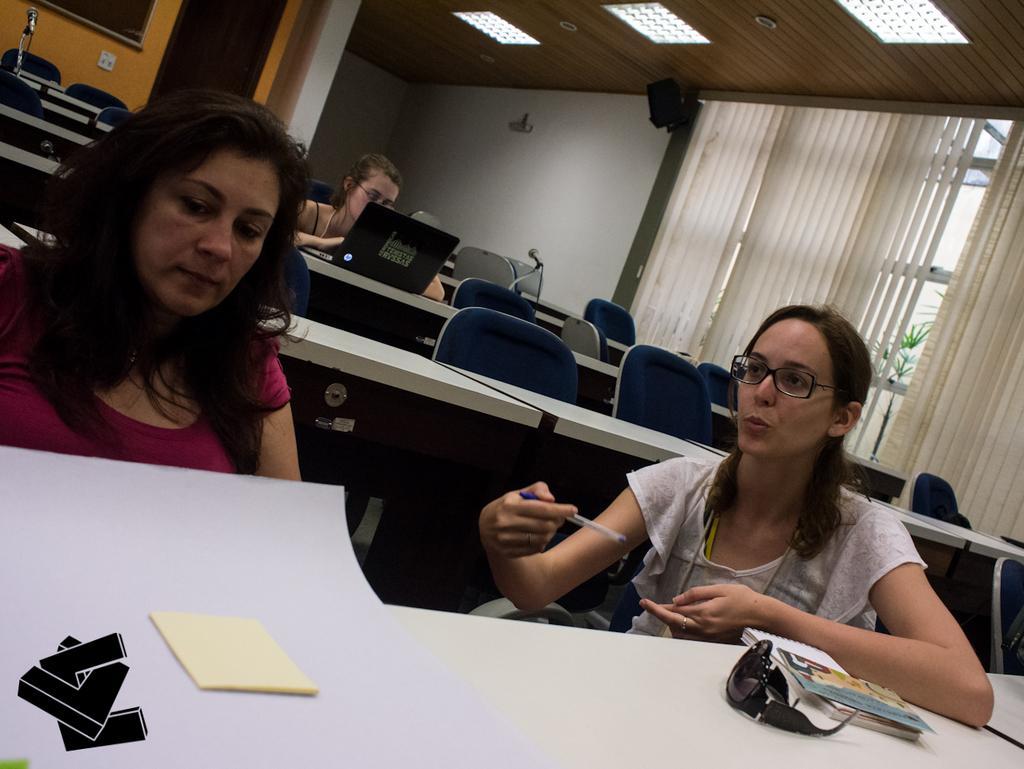How would you summarize this image in a sentence or two? In the image we can see there are women sitting on the chair and there are papers and sunglasses kept on the table. There is a laptop kept on the table and there is a mic kept on the table. There is speaker box kept on the wall and there are lights on the top. 